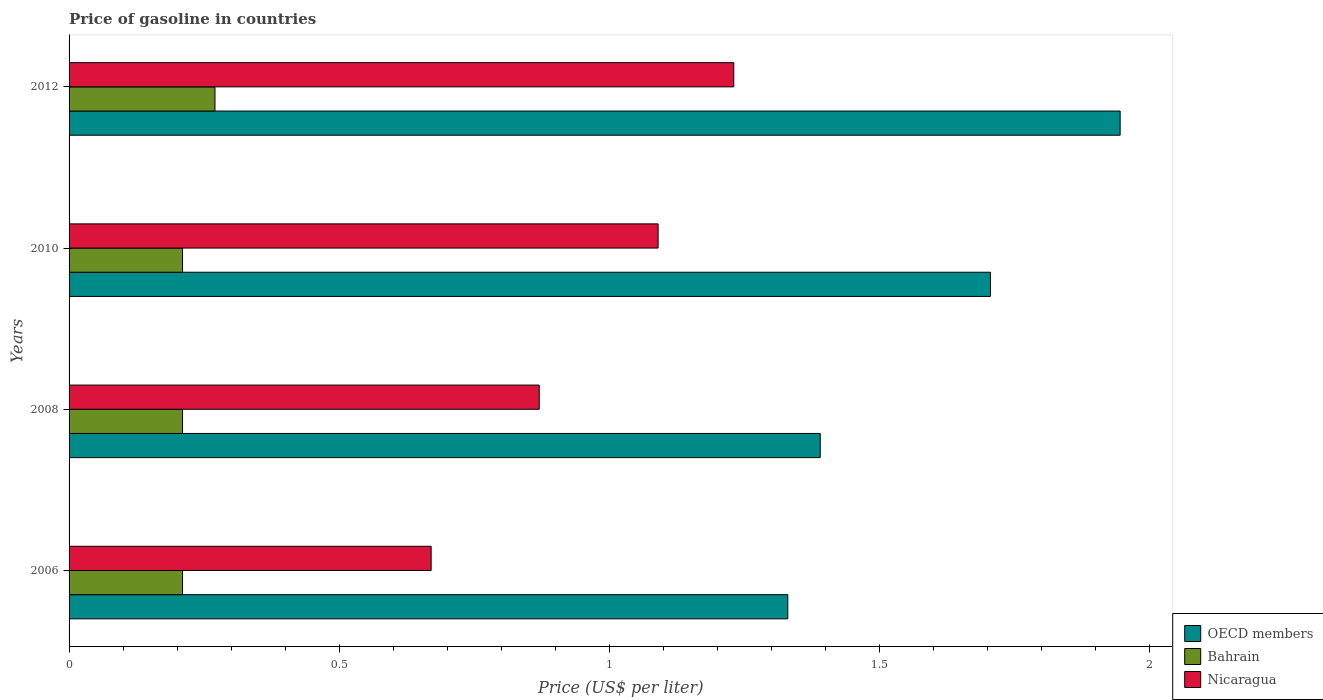How many groups of bars are there?
Keep it short and to the point. 4. Are the number of bars per tick equal to the number of legend labels?
Your response must be concise. Yes. Are the number of bars on each tick of the Y-axis equal?
Provide a short and direct response. Yes. How many bars are there on the 4th tick from the bottom?
Your answer should be very brief. 3. What is the price of gasoline in Nicaragua in 2006?
Provide a short and direct response. 0.67. Across all years, what is the maximum price of gasoline in Bahrain?
Provide a succinct answer. 0.27. Across all years, what is the minimum price of gasoline in Bahrain?
Keep it short and to the point. 0.21. In which year was the price of gasoline in Bahrain maximum?
Your answer should be compact. 2012. What is the difference between the price of gasoline in Nicaragua in 2006 and that in 2008?
Give a very brief answer. -0.2. What is the difference between the price of gasoline in Nicaragua in 2010 and the price of gasoline in Bahrain in 2008?
Offer a very short reply. 0.88. What is the average price of gasoline in Bahrain per year?
Ensure brevity in your answer.  0.23. In the year 2008, what is the difference between the price of gasoline in OECD members and price of gasoline in Nicaragua?
Make the answer very short. 0.52. In how many years, is the price of gasoline in Bahrain greater than 0.1 US$?
Make the answer very short. 4. What is the ratio of the price of gasoline in Bahrain in 2006 to that in 2012?
Give a very brief answer. 0.78. What is the difference between the highest and the second highest price of gasoline in Bahrain?
Give a very brief answer. 0.06. What is the difference between the highest and the lowest price of gasoline in Nicaragua?
Provide a succinct answer. 0.56. In how many years, is the price of gasoline in Nicaragua greater than the average price of gasoline in Nicaragua taken over all years?
Offer a terse response. 2. Is the sum of the price of gasoline in Bahrain in 2010 and 2012 greater than the maximum price of gasoline in OECD members across all years?
Offer a terse response. No. What does the 1st bar from the top in 2008 represents?
Keep it short and to the point. Nicaragua. What does the 1st bar from the bottom in 2008 represents?
Ensure brevity in your answer.  OECD members. How many bars are there?
Your answer should be compact. 12. How many years are there in the graph?
Your answer should be very brief. 4. What is the difference between two consecutive major ticks on the X-axis?
Offer a terse response. 0.5. Are the values on the major ticks of X-axis written in scientific E-notation?
Keep it short and to the point. No. Does the graph contain grids?
Ensure brevity in your answer.  No. How are the legend labels stacked?
Offer a very short reply. Vertical. What is the title of the graph?
Give a very brief answer. Price of gasoline in countries. What is the label or title of the X-axis?
Give a very brief answer. Price (US$ per liter). What is the label or title of the Y-axis?
Offer a terse response. Years. What is the Price (US$ per liter) in OECD members in 2006?
Offer a very short reply. 1.33. What is the Price (US$ per liter) of Bahrain in 2006?
Make the answer very short. 0.21. What is the Price (US$ per liter) of Nicaragua in 2006?
Your response must be concise. 0.67. What is the Price (US$ per liter) of OECD members in 2008?
Your response must be concise. 1.39. What is the Price (US$ per liter) in Bahrain in 2008?
Offer a terse response. 0.21. What is the Price (US$ per liter) of Nicaragua in 2008?
Give a very brief answer. 0.87. What is the Price (US$ per liter) of OECD members in 2010?
Offer a terse response. 1.71. What is the Price (US$ per liter) of Bahrain in 2010?
Offer a terse response. 0.21. What is the Price (US$ per liter) in Nicaragua in 2010?
Offer a terse response. 1.09. What is the Price (US$ per liter) of OECD members in 2012?
Provide a succinct answer. 1.95. What is the Price (US$ per liter) in Bahrain in 2012?
Your answer should be compact. 0.27. What is the Price (US$ per liter) in Nicaragua in 2012?
Make the answer very short. 1.23. Across all years, what is the maximum Price (US$ per liter) of OECD members?
Your answer should be compact. 1.95. Across all years, what is the maximum Price (US$ per liter) of Bahrain?
Your answer should be very brief. 0.27. Across all years, what is the maximum Price (US$ per liter) of Nicaragua?
Ensure brevity in your answer.  1.23. Across all years, what is the minimum Price (US$ per liter) in OECD members?
Make the answer very short. 1.33. Across all years, what is the minimum Price (US$ per liter) of Bahrain?
Provide a short and direct response. 0.21. Across all years, what is the minimum Price (US$ per liter) in Nicaragua?
Provide a short and direct response. 0.67. What is the total Price (US$ per liter) of OECD members in the graph?
Provide a short and direct response. 6.37. What is the total Price (US$ per liter) in Bahrain in the graph?
Give a very brief answer. 0.9. What is the total Price (US$ per liter) in Nicaragua in the graph?
Offer a terse response. 3.86. What is the difference between the Price (US$ per liter) of OECD members in 2006 and that in 2008?
Make the answer very short. -0.06. What is the difference between the Price (US$ per liter) in Bahrain in 2006 and that in 2008?
Provide a succinct answer. 0. What is the difference between the Price (US$ per liter) of Nicaragua in 2006 and that in 2008?
Offer a very short reply. -0.2. What is the difference between the Price (US$ per liter) in OECD members in 2006 and that in 2010?
Offer a terse response. -0.38. What is the difference between the Price (US$ per liter) of Bahrain in 2006 and that in 2010?
Offer a terse response. 0. What is the difference between the Price (US$ per liter) in Nicaragua in 2006 and that in 2010?
Your answer should be very brief. -0.42. What is the difference between the Price (US$ per liter) in OECD members in 2006 and that in 2012?
Provide a succinct answer. -0.61. What is the difference between the Price (US$ per liter) of Bahrain in 2006 and that in 2012?
Ensure brevity in your answer.  -0.06. What is the difference between the Price (US$ per liter) in Nicaragua in 2006 and that in 2012?
Provide a short and direct response. -0.56. What is the difference between the Price (US$ per liter) in OECD members in 2008 and that in 2010?
Your answer should be very brief. -0.32. What is the difference between the Price (US$ per liter) in Bahrain in 2008 and that in 2010?
Provide a succinct answer. 0. What is the difference between the Price (US$ per liter) of Nicaragua in 2008 and that in 2010?
Your answer should be compact. -0.22. What is the difference between the Price (US$ per liter) of OECD members in 2008 and that in 2012?
Offer a terse response. -0.56. What is the difference between the Price (US$ per liter) of Bahrain in 2008 and that in 2012?
Your response must be concise. -0.06. What is the difference between the Price (US$ per liter) in Nicaragua in 2008 and that in 2012?
Ensure brevity in your answer.  -0.36. What is the difference between the Price (US$ per liter) in OECD members in 2010 and that in 2012?
Provide a short and direct response. -0.24. What is the difference between the Price (US$ per liter) in Bahrain in 2010 and that in 2012?
Ensure brevity in your answer.  -0.06. What is the difference between the Price (US$ per liter) of Nicaragua in 2010 and that in 2012?
Ensure brevity in your answer.  -0.14. What is the difference between the Price (US$ per liter) in OECD members in 2006 and the Price (US$ per liter) in Bahrain in 2008?
Your answer should be compact. 1.12. What is the difference between the Price (US$ per liter) in OECD members in 2006 and the Price (US$ per liter) in Nicaragua in 2008?
Your answer should be very brief. 0.46. What is the difference between the Price (US$ per liter) in Bahrain in 2006 and the Price (US$ per liter) in Nicaragua in 2008?
Your response must be concise. -0.66. What is the difference between the Price (US$ per liter) of OECD members in 2006 and the Price (US$ per liter) of Bahrain in 2010?
Provide a succinct answer. 1.12. What is the difference between the Price (US$ per liter) in OECD members in 2006 and the Price (US$ per liter) in Nicaragua in 2010?
Your answer should be very brief. 0.24. What is the difference between the Price (US$ per liter) of Bahrain in 2006 and the Price (US$ per liter) of Nicaragua in 2010?
Offer a terse response. -0.88. What is the difference between the Price (US$ per liter) of OECD members in 2006 and the Price (US$ per liter) of Bahrain in 2012?
Give a very brief answer. 1.06. What is the difference between the Price (US$ per liter) of OECD members in 2006 and the Price (US$ per liter) of Nicaragua in 2012?
Make the answer very short. 0.1. What is the difference between the Price (US$ per liter) in Bahrain in 2006 and the Price (US$ per liter) in Nicaragua in 2012?
Offer a very short reply. -1.02. What is the difference between the Price (US$ per liter) in OECD members in 2008 and the Price (US$ per liter) in Bahrain in 2010?
Your answer should be very brief. 1.18. What is the difference between the Price (US$ per liter) of OECD members in 2008 and the Price (US$ per liter) of Nicaragua in 2010?
Offer a terse response. 0.3. What is the difference between the Price (US$ per liter) in Bahrain in 2008 and the Price (US$ per liter) in Nicaragua in 2010?
Make the answer very short. -0.88. What is the difference between the Price (US$ per liter) in OECD members in 2008 and the Price (US$ per liter) in Bahrain in 2012?
Your response must be concise. 1.12. What is the difference between the Price (US$ per liter) in OECD members in 2008 and the Price (US$ per liter) in Nicaragua in 2012?
Your response must be concise. 0.16. What is the difference between the Price (US$ per liter) in Bahrain in 2008 and the Price (US$ per liter) in Nicaragua in 2012?
Provide a short and direct response. -1.02. What is the difference between the Price (US$ per liter) of OECD members in 2010 and the Price (US$ per liter) of Bahrain in 2012?
Your answer should be very brief. 1.44. What is the difference between the Price (US$ per liter) in OECD members in 2010 and the Price (US$ per liter) in Nicaragua in 2012?
Your answer should be very brief. 0.47. What is the difference between the Price (US$ per liter) of Bahrain in 2010 and the Price (US$ per liter) of Nicaragua in 2012?
Ensure brevity in your answer.  -1.02. What is the average Price (US$ per liter) in OECD members per year?
Your answer should be very brief. 1.59. What is the average Price (US$ per liter) in Bahrain per year?
Ensure brevity in your answer.  0.23. What is the average Price (US$ per liter) in Nicaragua per year?
Offer a terse response. 0.96. In the year 2006, what is the difference between the Price (US$ per liter) in OECD members and Price (US$ per liter) in Bahrain?
Provide a succinct answer. 1.12. In the year 2006, what is the difference between the Price (US$ per liter) of OECD members and Price (US$ per liter) of Nicaragua?
Make the answer very short. 0.66. In the year 2006, what is the difference between the Price (US$ per liter) of Bahrain and Price (US$ per liter) of Nicaragua?
Keep it short and to the point. -0.46. In the year 2008, what is the difference between the Price (US$ per liter) of OECD members and Price (US$ per liter) of Bahrain?
Ensure brevity in your answer.  1.18. In the year 2008, what is the difference between the Price (US$ per liter) in OECD members and Price (US$ per liter) in Nicaragua?
Offer a terse response. 0.52. In the year 2008, what is the difference between the Price (US$ per liter) in Bahrain and Price (US$ per liter) in Nicaragua?
Ensure brevity in your answer.  -0.66. In the year 2010, what is the difference between the Price (US$ per liter) in OECD members and Price (US$ per liter) in Bahrain?
Make the answer very short. 1.5. In the year 2010, what is the difference between the Price (US$ per liter) of OECD members and Price (US$ per liter) of Nicaragua?
Your response must be concise. 0.61. In the year 2010, what is the difference between the Price (US$ per liter) of Bahrain and Price (US$ per liter) of Nicaragua?
Make the answer very short. -0.88. In the year 2012, what is the difference between the Price (US$ per liter) of OECD members and Price (US$ per liter) of Bahrain?
Make the answer very short. 1.68. In the year 2012, what is the difference between the Price (US$ per liter) of OECD members and Price (US$ per liter) of Nicaragua?
Give a very brief answer. 0.71. In the year 2012, what is the difference between the Price (US$ per liter) of Bahrain and Price (US$ per liter) of Nicaragua?
Your answer should be compact. -0.96. What is the ratio of the Price (US$ per liter) in OECD members in 2006 to that in 2008?
Give a very brief answer. 0.96. What is the ratio of the Price (US$ per liter) of Bahrain in 2006 to that in 2008?
Ensure brevity in your answer.  1. What is the ratio of the Price (US$ per liter) in Nicaragua in 2006 to that in 2008?
Give a very brief answer. 0.77. What is the ratio of the Price (US$ per liter) in OECD members in 2006 to that in 2010?
Give a very brief answer. 0.78. What is the ratio of the Price (US$ per liter) of Nicaragua in 2006 to that in 2010?
Make the answer very short. 0.61. What is the ratio of the Price (US$ per liter) of OECD members in 2006 to that in 2012?
Make the answer very short. 0.68. What is the ratio of the Price (US$ per liter) in Bahrain in 2006 to that in 2012?
Provide a succinct answer. 0.78. What is the ratio of the Price (US$ per liter) in Nicaragua in 2006 to that in 2012?
Ensure brevity in your answer.  0.54. What is the ratio of the Price (US$ per liter) of OECD members in 2008 to that in 2010?
Make the answer very short. 0.82. What is the ratio of the Price (US$ per liter) in Nicaragua in 2008 to that in 2010?
Offer a very short reply. 0.8. What is the ratio of the Price (US$ per liter) of OECD members in 2008 to that in 2012?
Your response must be concise. 0.71. What is the ratio of the Price (US$ per liter) of Bahrain in 2008 to that in 2012?
Provide a succinct answer. 0.78. What is the ratio of the Price (US$ per liter) in Nicaragua in 2008 to that in 2012?
Your answer should be very brief. 0.71. What is the ratio of the Price (US$ per liter) of OECD members in 2010 to that in 2012?
Offer a very short reply. 0.88. What is the ratio of the Price (US$ per liter) of Bahrain in 2010 to that in 2012?
Provide a succinct answer. 0.78. What is the ratio of the Price (US$ per liter) in Nicaragua in 2010 to that in 2012?
Offer a terse response. 0.89. What is the difference between the highest and the second highest Price (US$ per liter) in OECD members?
Ensure brevity in your answer.  0.24. What is the difference between the highest and the second highest Price (US$ per liter) of Nicaragua?
Provide a succinct answer. 0.14. What is the difference between the highest and the lowest Price (US$ per liter) of OECD members?
Make the answer very short. 0.61. What is the difference between the highest and the lowest Price (US$ per liter) of Nicaragua?
Make the answer very short. 0.56. 